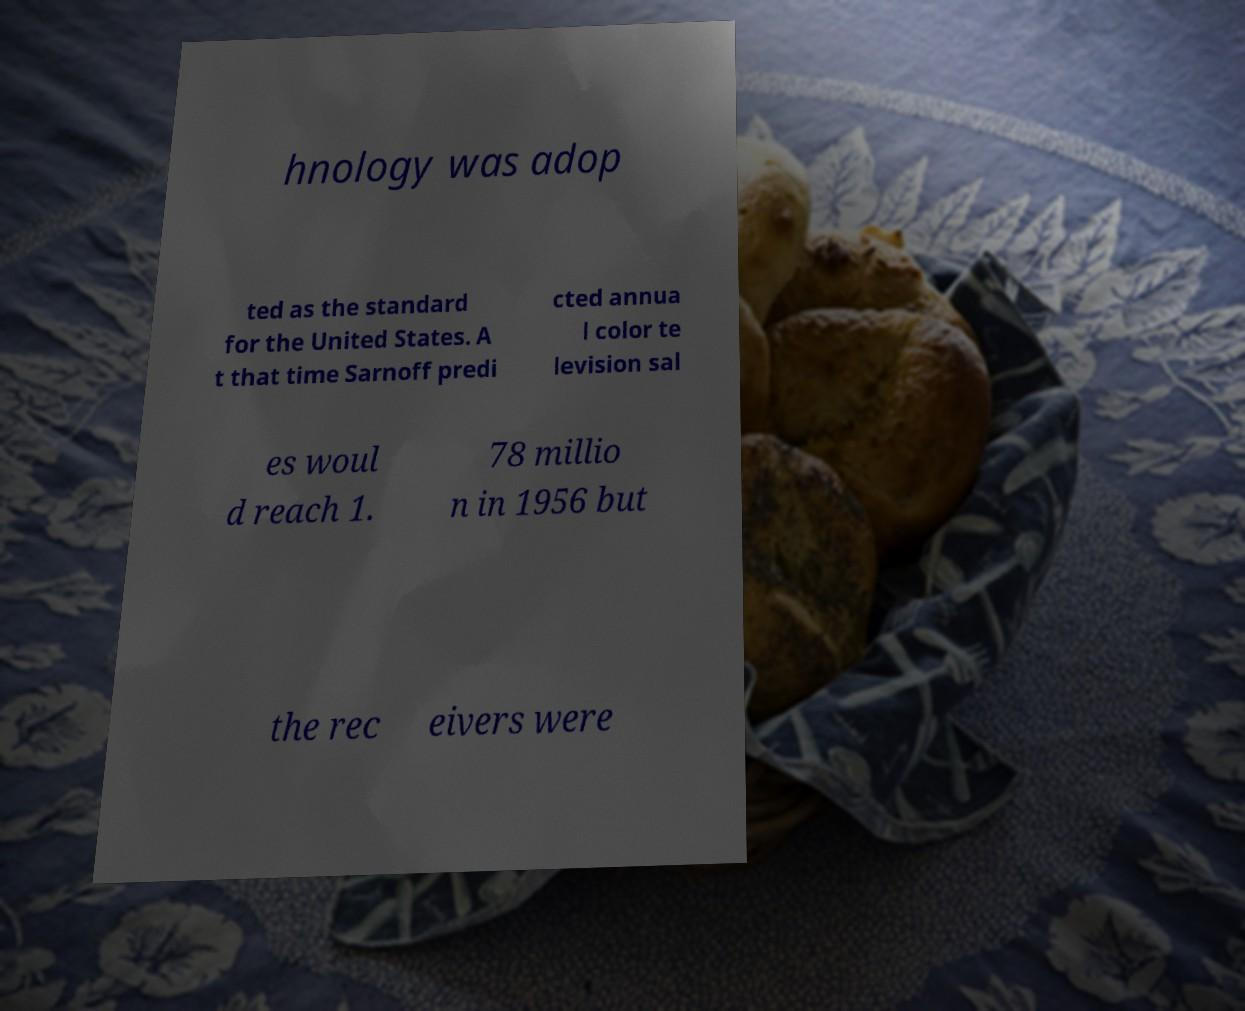Could you extract and type out the text from this image? hnology was adop ted as the standard for the United States. A t that time Sarnoff predi cted annua l color te levision sal es woul d reach 1. 78 millio n in 1956 but the rec eivers were 